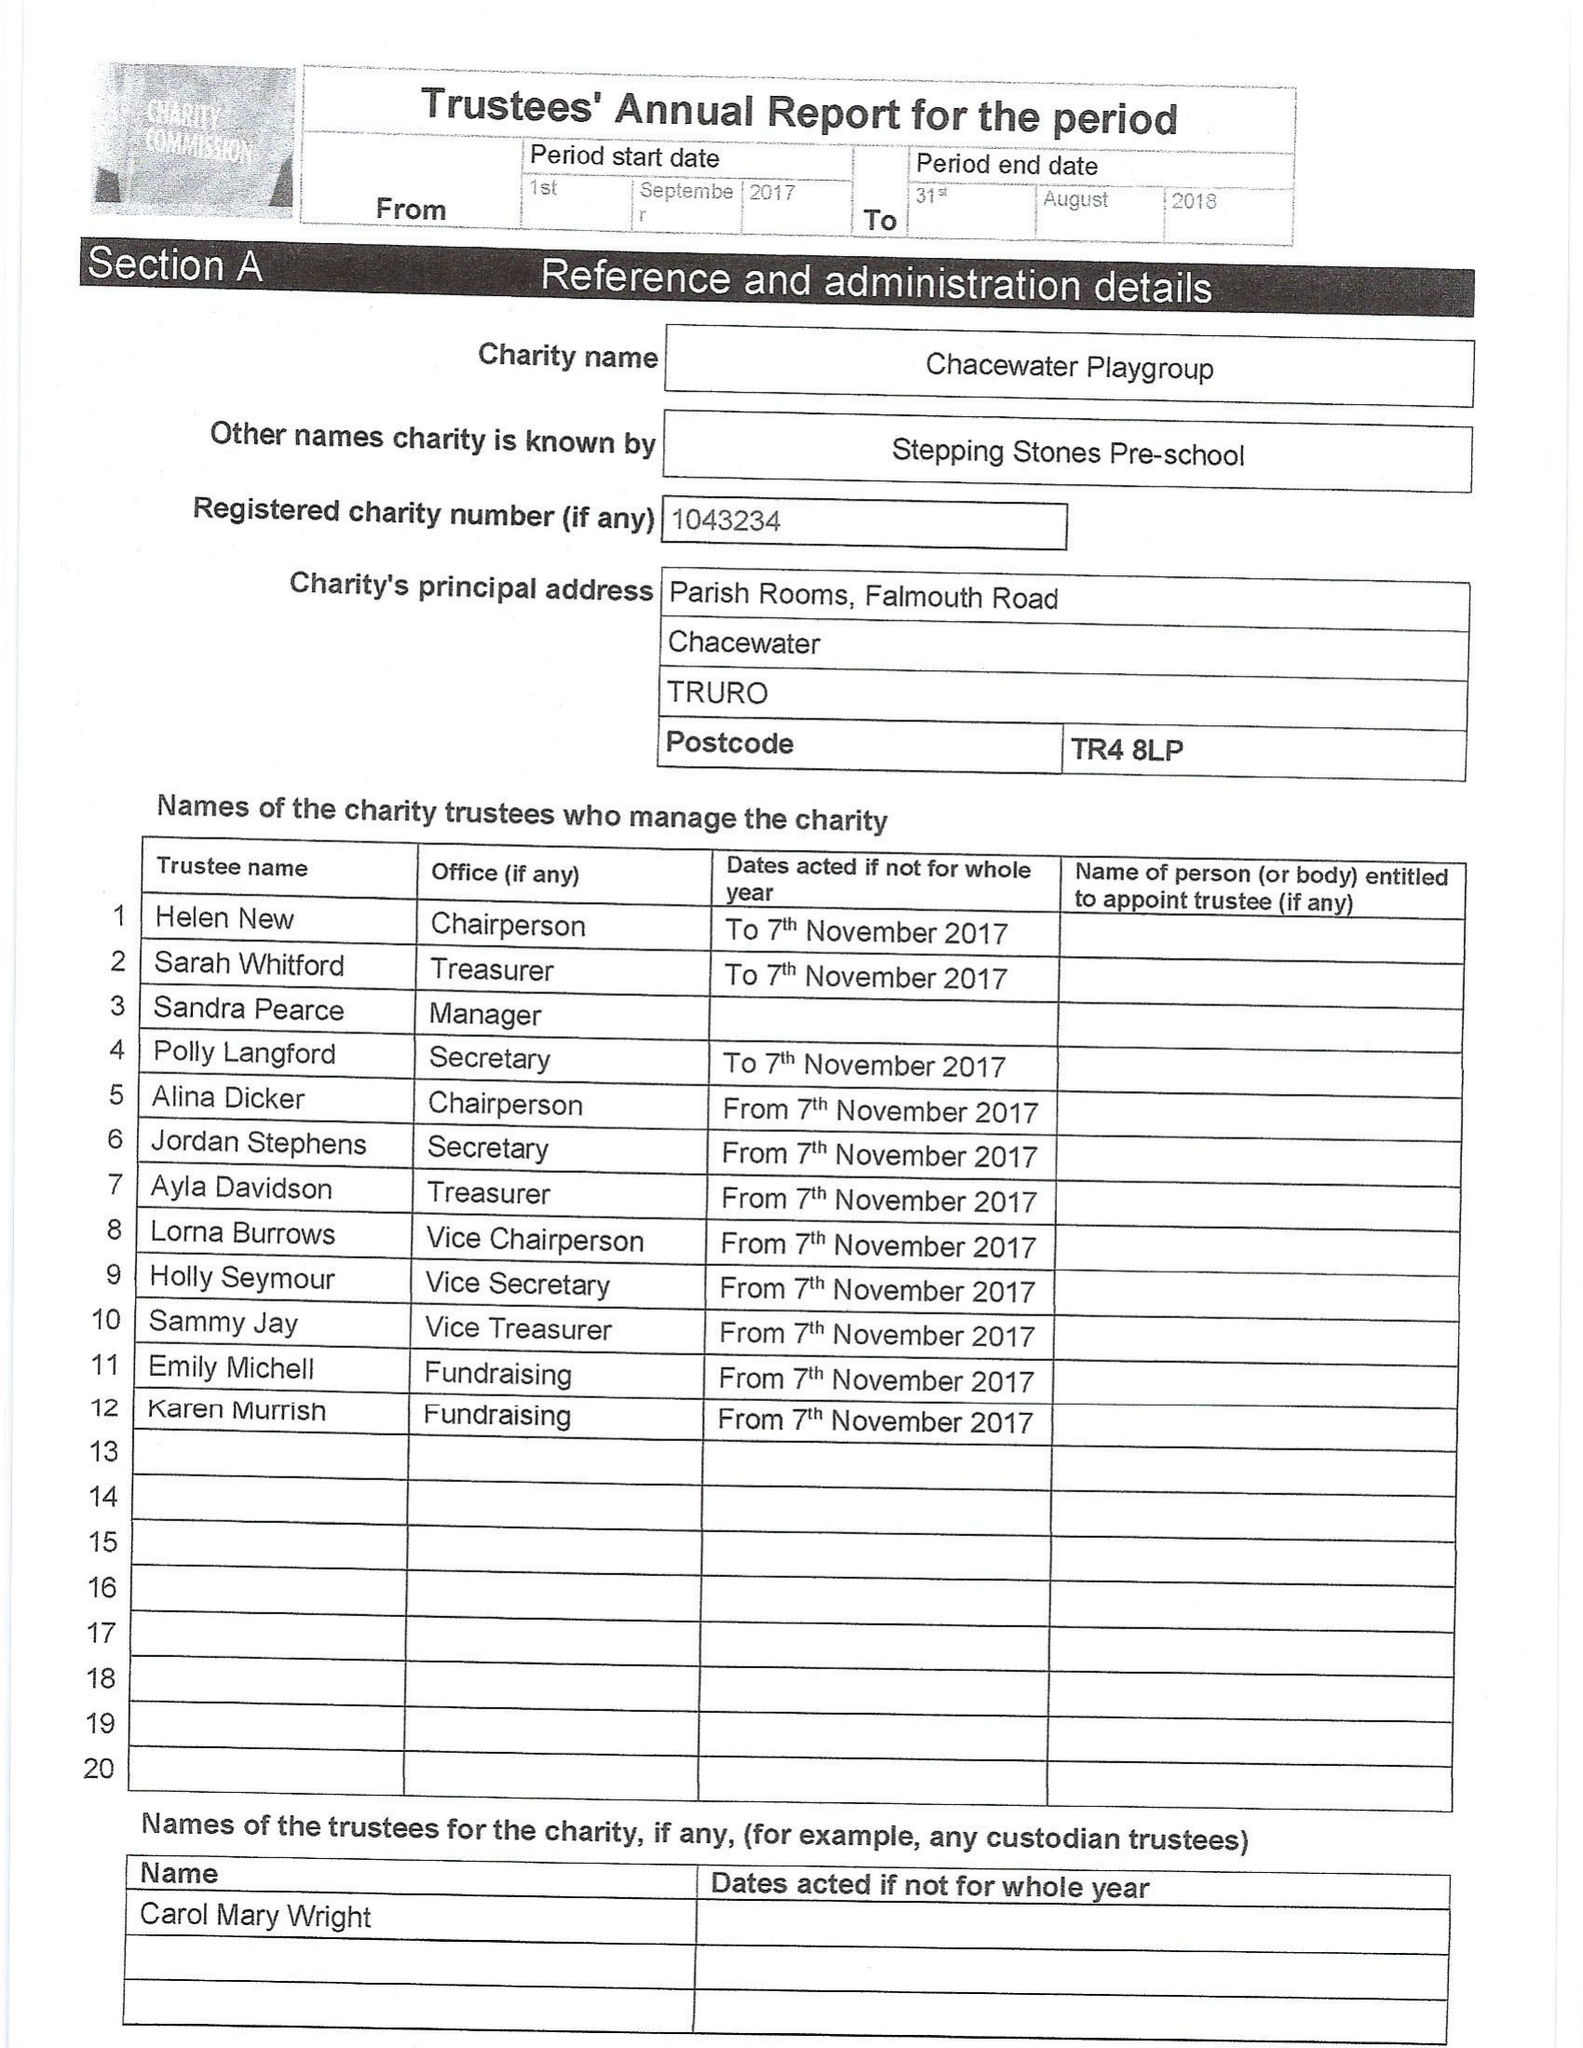What is the value for the address__post_town?
Answer the question using a single word or phrase. TRURO 